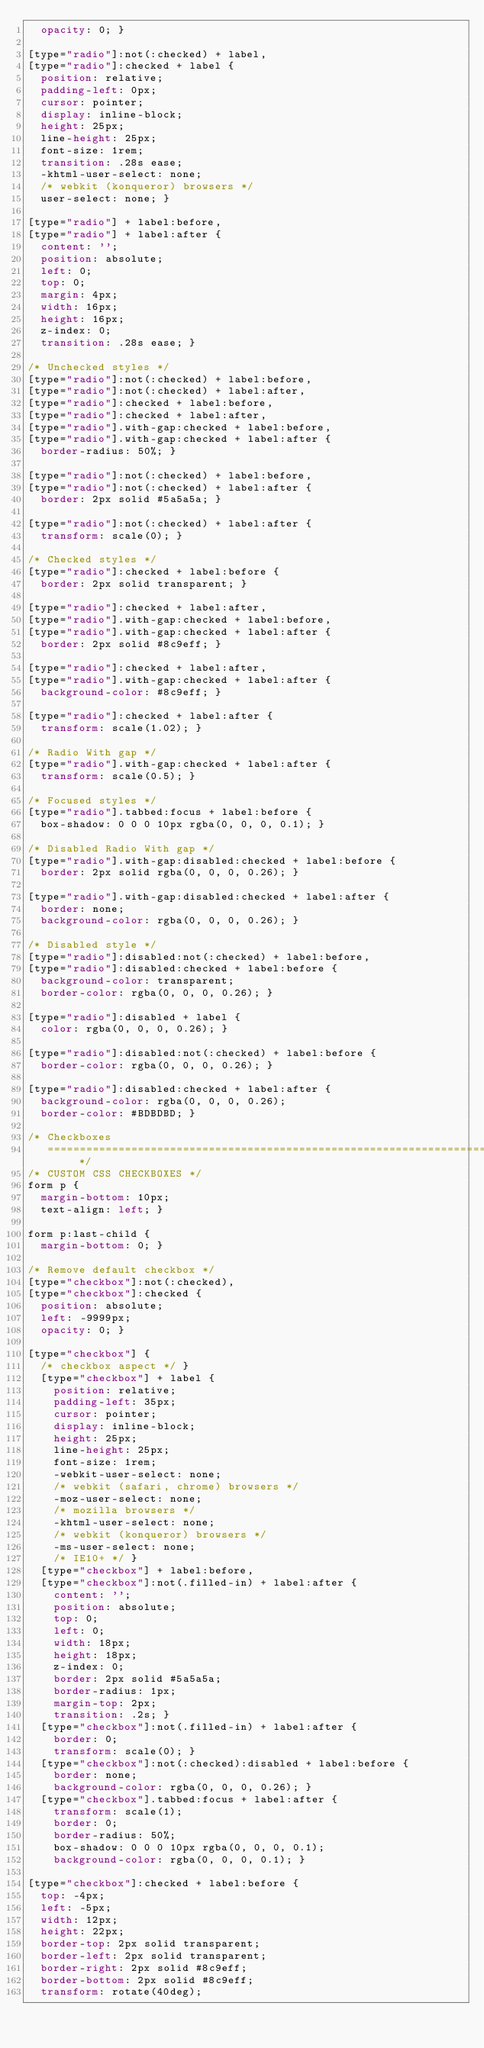Convert code to text. <code><loc_0><loc_0><loc_500><loc_500><_CSS_>  opacity: 0; }

[type="radio"]:not(:checked) + label,
[type="radio"]:checked + label {
  position: relative;
  padding-left: 0px;
  cursor: pointer;
  display: inline-block;
  height: 25px;
  line-height: 25px;
  font-size: 1rem;
  transition: .28s ease;
  -khtml-user-select: none;
  /* webkit (konqueror) browsers */
  user-select: none; }

[type="radio"] + label:before,
[type="radio"] + label:after {
  content: '';
  position: absolute;
  left: 0;
  top: 0;
  margin: 4px;
  width: 16px;
  height: 16px;
  z-index: 0;
  transition: .28s ease; }

/* Unchecked styles */
[type="radio"]:not(:checked) + label:before,
[type="radio"]:not(:checked) + label:after,
[type="radio"]:checked + label:before,
[type="radio"]:checked + label:after,
[type="radio"].with-gap:checked + label:before,
[type="radio"].with-gap:checked + label:after {
  border-radius: 50%; }

[type="radio"]:not(:checked) + label:before,
[type="radio"]:not(:checked) + label:after {
  border: 2px solid #5a5a5a; }

[type="radio"]:not(:checked) + label:after {
  transform: scale(0); }

/* Checked styles */
[type="radio"]:checked + label:before {
  border: 2px solid transparent; }

[type="radio"]:checked + label:after,
[type="radio"].with-gap:checked + label:before,
[type="radio"].with-gap:checked + label:after {
  border: 2px solid #8c9eff; }

[type="radio"]:checked + label:after,
[type="radio"].with-gap:checked + label:after {
  background-color: #8c9eff; }

[type="radio"]:checked + label:after {
  transform: scale(1.02); }

/* Radio With gap */
[type="radio"].with-gap:checked + label:after {
  transform: scale(0.5); }

/* Focused styles */
[type="radio"].tabbed:focus + label:before {
  box-shadow: 0 0 0 10px rgba(0, 0, 0, 0.1); }

/* Disabled Radio With gap */
[type="radio"].with-gap:disabled:checked + label:before {
  border: 2px solid rgba(0, 0, 0, 0.26); }

[type="radio"].with-gap:disabled:checked + label:after {
  border: none;
  background-color: rgba(0, 0, 0, 0.26); }

/* Disabled style */
[type="radio"]:disabled:not(:checked) + label:before,
[type="radio"]:disabled:checked + label:before {
  background-color: transparent;
  border-color: rgba(0, 0, 0, 0.26); }

[type="radio"]:disabled + label {
  color: rgba(0, 0, 0, 0.26); }

[type="radio"]:disabled:not(:checked) + label:before {
  border-color: rgba(0, 0, 0, 0.26); }

[type="radio"]:disabled:checked + label:after {
  background-color: rgba(0, 0, 0, 0.26);
  border-color: #BDBDBD; }

/* Checkboxes
   ========================================================================== */
/* CUSTOM CSS CHECKBOXES */
form p {
  margin-bottom: 10px;
  text-align: left; }

form p:last-child {
  margin-bottom: 0; }

/* Remove default checkbox */
[type="checkbox"]:not(:checked),
[type="checkbox"]:checked {
  position: absolute;
  left: -9999px;
  opacity: 0; }

[type="checkbox"] {
  /* checkbox aspect */ }
  [type="checkbox"] + label {
    position: relative;
    padding-left: 35px;
    cursor: pointer;
    display: inline-block;
    height: 25px;
    line-height: 25px;
    font-size: 1rem;
    -webkit-user-select: none;
    /* webkit (safari, chrome) browsers */
    -moz-user-select: none;
    /* mozilla browsers */
    -khtml-user-select: none;
    /* webkit (konqueror) browsers */
    -ms-user-select: none;
    /* IE10+ */ }
  [type="checkbox"] + label:before,
  [type="checkbox"]:not(.filled-in) + label:after {
    content: '';
    position: absolute;
    top: 0;
    left: 0;
    width: 18px;
    height: 18px;
    z-index: 0;
    border: 2px solid #5a5a5a;
    border-radius: 1px;
    margin-top: 2px;
    transition: .2s; }
  [type="checkbox"]:not(.filled-in) + label:after {
    border: 0;
    transform: scale(0); }
  [type="checkbox"]:not(:checked):disabled + label:before {
    border: none;
    background-color: rgba(0, 0, 0, 0.26); }
  [type="checkbox"].tabbed:focus + label:after {
    transform: scale(1);
    border: 0;
    border-radius: 50%;
    box-shadow: 0 0 0 10px rgba(0, 0, 0, 0.1);
    background-color: rgba(0, 0, 0, 0.1); }

[type="checkbox"]:checked + label:before {
  top: -4px;
  left: -5px;
  width: 12px;
  height: 22px;
  border-top: 2px solid transparent;
  border-left: 2px solid transparent;
  border-right: 2px solid #8c9eff;
  border-bottom: 2px solid #8c9eff;
  transform: rotate(40deg);</code> 